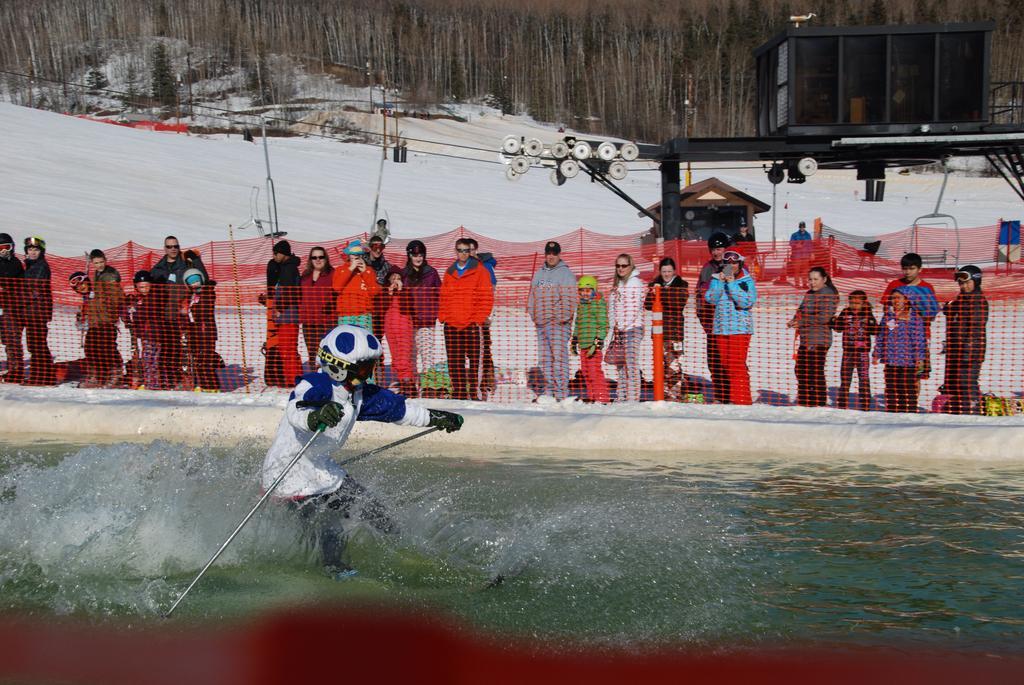Could you give a brief overview of what you see in this image? In this image in the center there is a man surfing on water. In the background there is a red colour net and there are persons standing and there is snow on the ground and there are trees and there are rooms. 